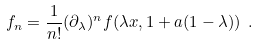Convert formula to latex. <formula><loc_0><loc_0><loc_500><loc_500>f _ { n } = \frac { 1 } { n ! } ( \partial _ { \lambda } ) ^ { n } f ( \lambda x , 1 + a ( 1 - \lambda ) ) \ .</formula> 